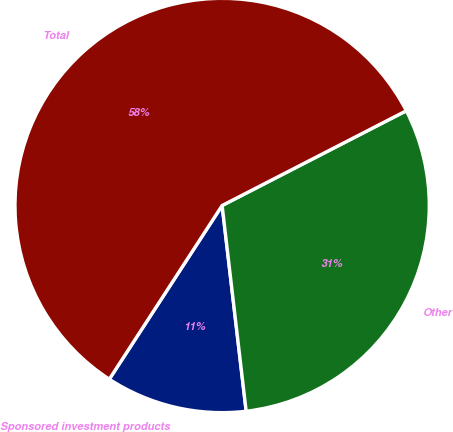Convert chart. <chart><loc_0><loc_0><loc_500><loc_500><pie_chart><fcel>Sponsored investment products<fcel>Other<fcel>Total<nl><fcel>11.02%<fcel>30.71%<fcel>58.27%<nl></chart> 